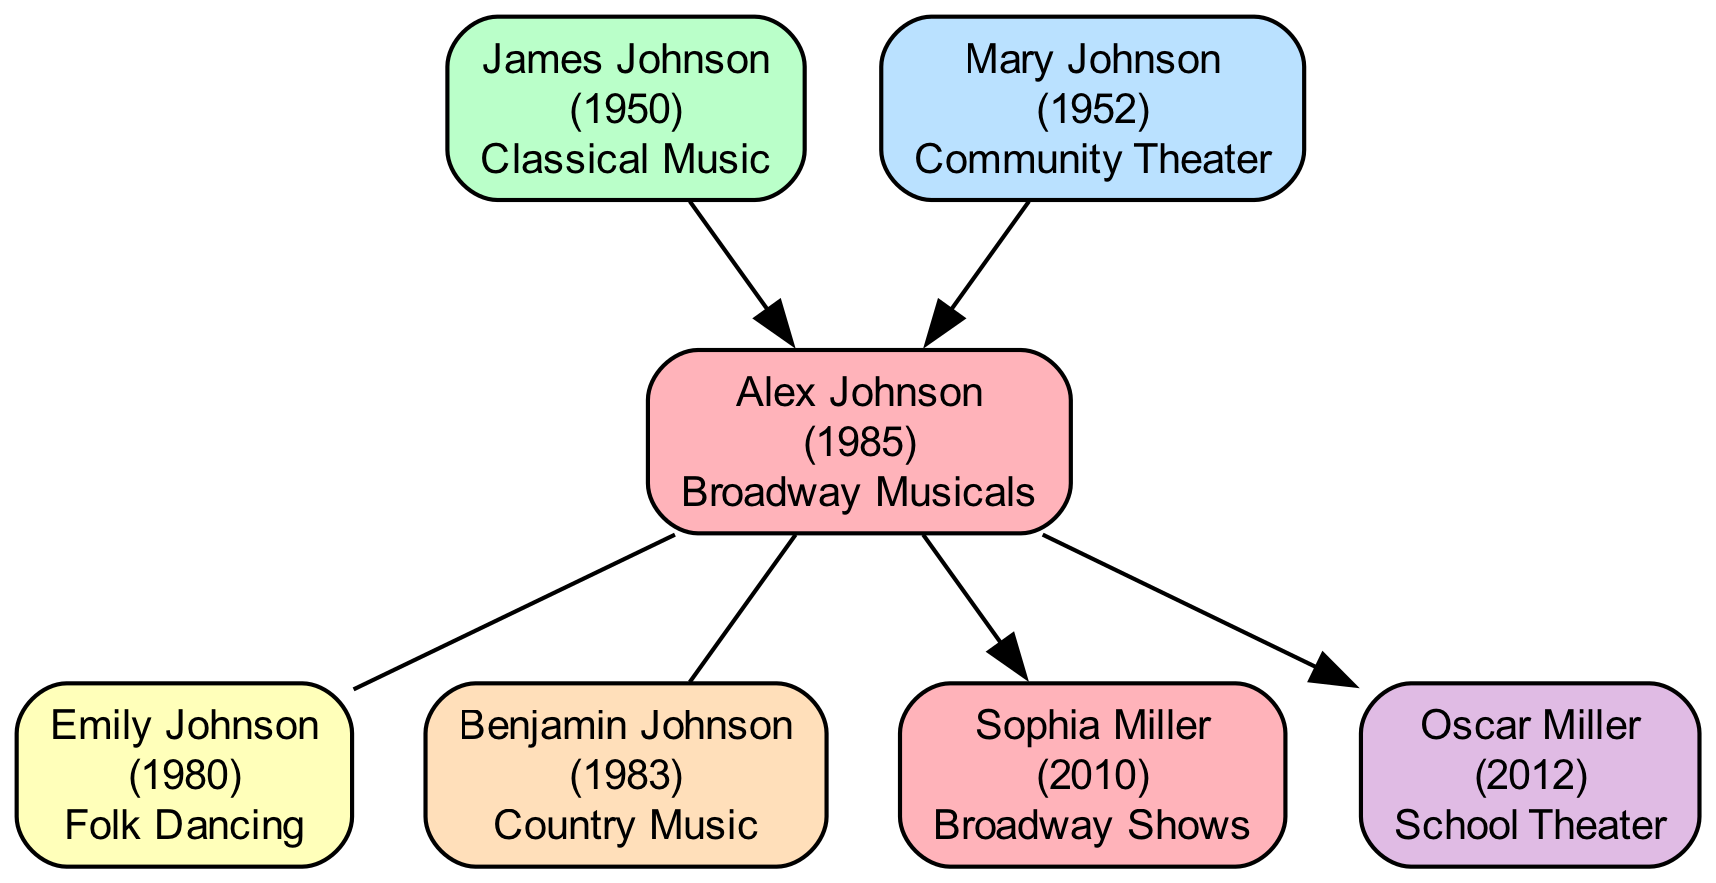What is Alex Johnson's birth year? The diagram indicates that Alex Johnson was born in 1985, which is directly noted in his node.
Answer: 1985 What type of performing arts interest does Mary Johnson have? In the diagram, Mary's node specifies her interest as "Community Theater," which is labeled clearly.
Answer: Community Theater How many children does Alex Johnson have? By counting the nodes connected as children to Alex Johnson, we find two: Sophia Miller and Oscar Miller.
Answer: 2 What is the relationship between Benjamin Johnson and Alex Johnson? The diagram shows that Benjamin Johnson is listed as Alex Johnson's brother, establishing a sibling relationship.
Answer: Brother Which family member has an interest in Folk Dancing? The node for Emily Johnson states her interest is "Folk Dancing," allowing for direct identification.
Answer: Emily Johnson Which performing arts interest is shared between Alex Johnson and Sophia Miller? Both Alex Johnson and Sophia Miller have interests related to "Broadway," with Alex listed under "Broadway Musicals" and Sophia under "Broadway Shows."
Answer: Broadway What is the birth year of the oldest family member? By examining the birth years of all family members listed, James Johnson, born in 1950, is the oldest.
Answer: 1950 Is Oscar Miller older or younger than Sophia Miller? By comparing their birth years, Oscar Miller, born in 2012, is younger than Sophia Miller, who was born in 2010.
Answer: Younger Which family member has an interest in Country Music? The diagram shows Benjamin Johnson, who is directly noted with the interest "Country Music."
Answer: Benjamin Johnson 